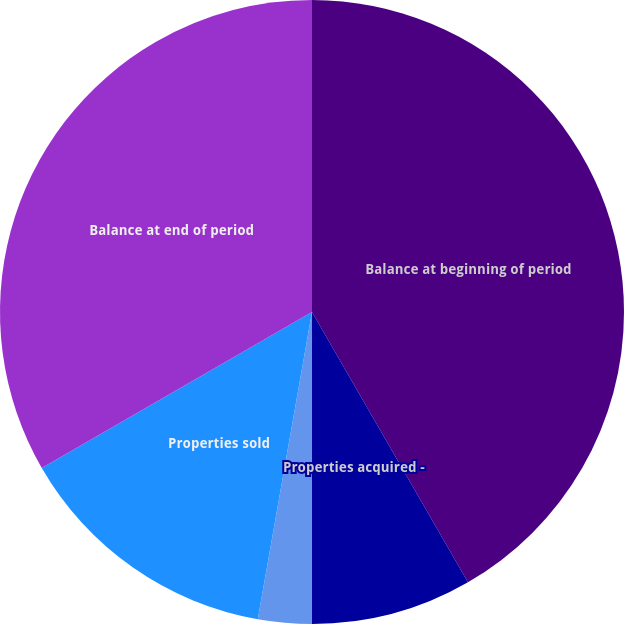<chart> <loc_0><loc_0><loc_500><loc_500><pie_chart><fcel>Balance at beginning of period<fcel>Properties acquired -<fcel>Valuation adjustments<fcel>Properties sold<fcel>Balance at end of period<nl><fcel>41.67%<fcel>8.33%<fcel>2.78%<fcel>13.89%<fcel>33.33%<nl></chart> 